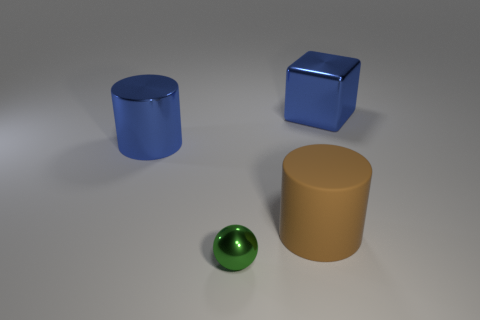Are there the same number of small spheres that are behind the tiny green metallic object and small green balls?
Give a very brief answer. No. What shape is the metal thing that is the same size as the blue cylinder?
Provide a succinct answer. Cube. What is the material of the blue cylinder?
Offer a terse response. Metal. What is the color of the object that is in front of the blue shiny block and on the right side of the green thing?
Offer a very short reply. Brown. Are there an equal number of metal balls to the left of the shiny cylinder and balls that are in front of the tiny ball?
Offer a very short reply. Yes. The small object that is the same material as the blue cube is what color?
Give a very brief answer. Green. There is a metallic block; does it have the same color as the metallic object in front of the big metallic cylinder?
Offer a terse response. No. There is a large blue thing in front of the big blue metallic thing that is right of the big blue metallic cylinder; are there any things that are in front of it?
Offer a very short reply. Yes. What shape is the blue thing that is the same material as the blue cube?
Ensure brevity in your answer.  Cylinder. Is there anything else that is the same shape as the green shiny thing?
Keep it short and to the point. No. 